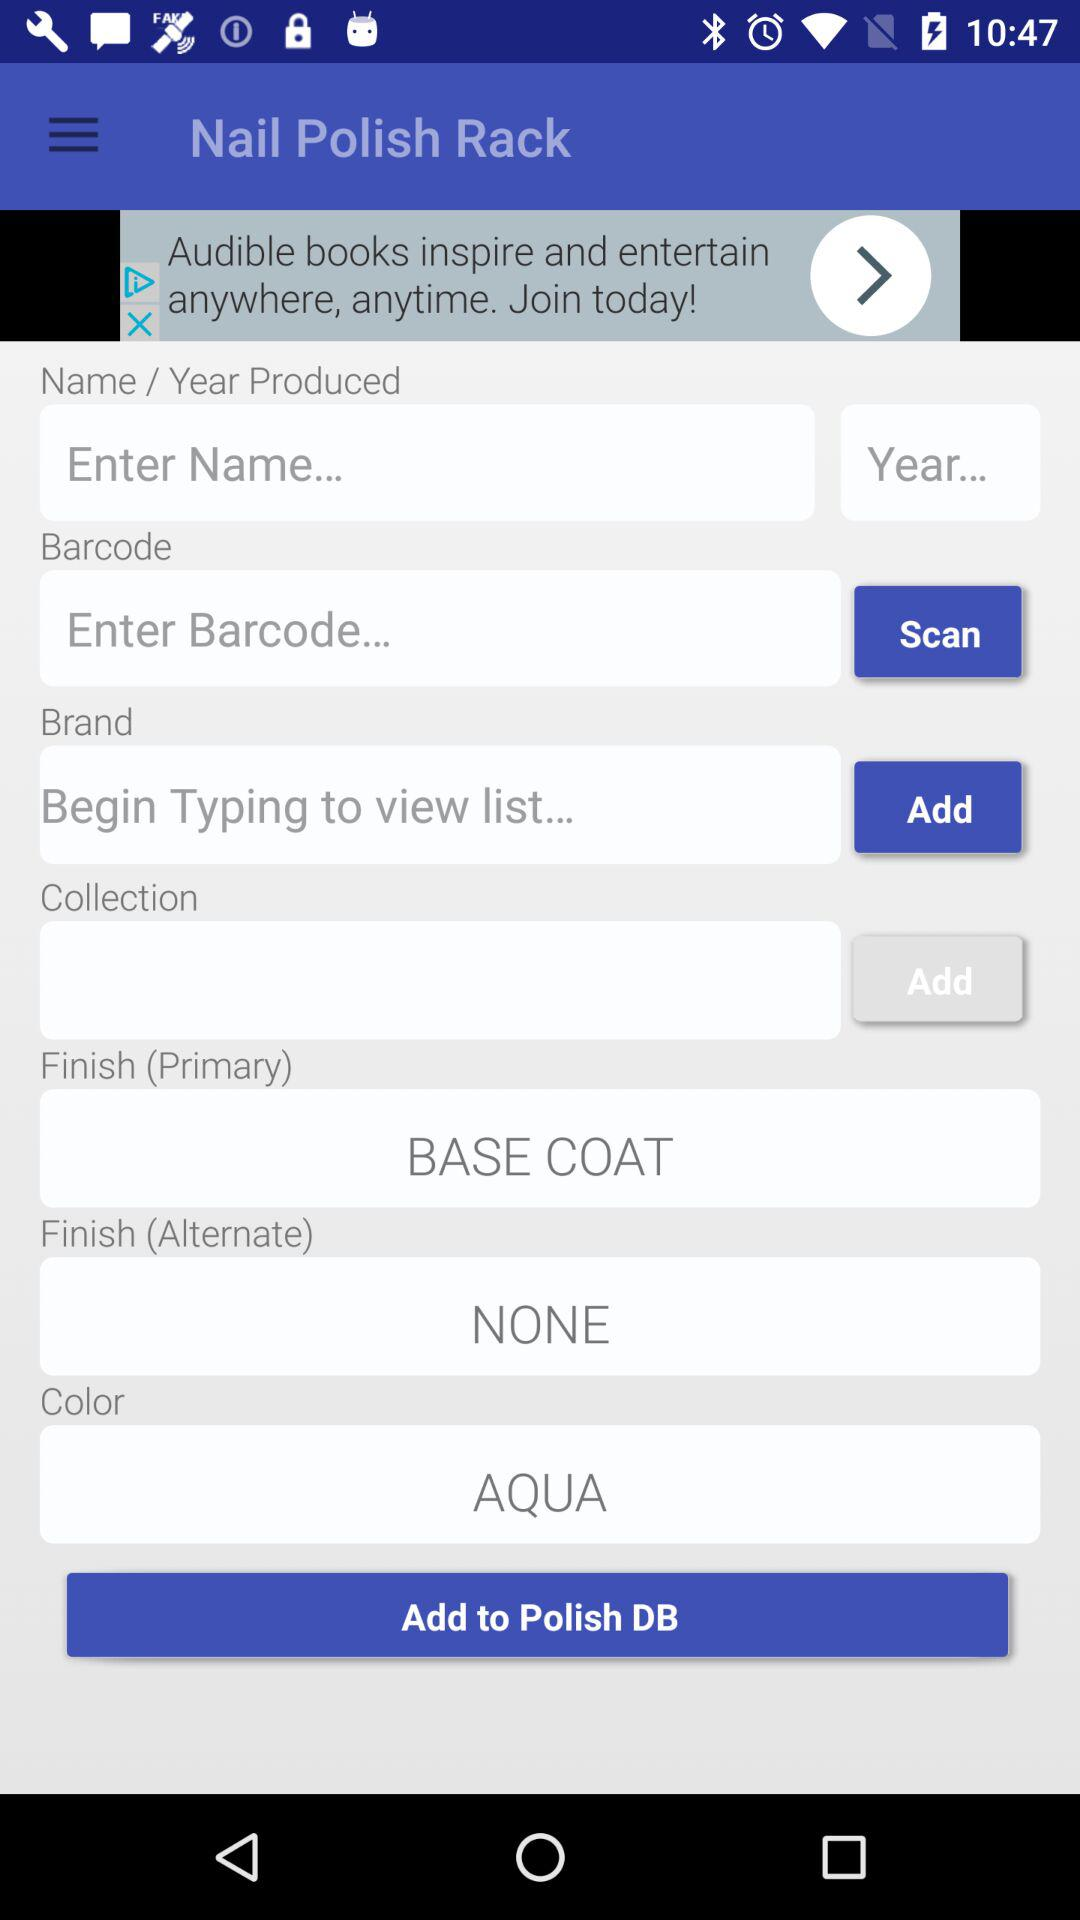What is the name of the application? The name of the application is "Nail Polish Rack". 